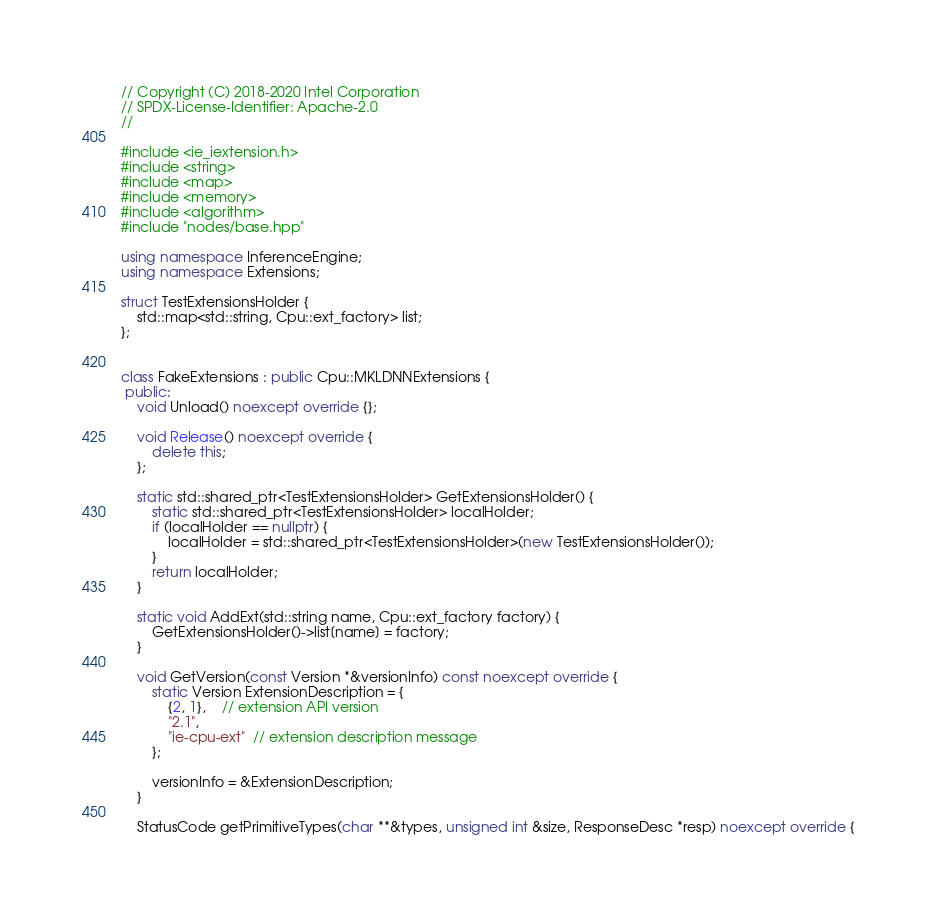<code> <loc_0><loc_0><loc_500><loc_500><_C++_>// Copyright (C) 2018-2020 Intel Corporation
// SPDX-License-Identifier: Apache-2.0
//

#include <ie_iextension.h>
#include <string>
#include <map>
#include <memory>
#include <algorithm>
#include "nodes/base.hpp"

using namespace InferenceEngine;
using namespace Extensions;

struct TestExtensionsHolder {
    std::map<std::string, Cpu::ext_factory> list;
};


class FakeExtensions : public Cpu::MKLDNNExtensions {
 public:
    void Unload() noexcept override {};

    void Release() noexcept override {
        delete this;
    };

    static std::shared_ptr<TestExtensionsHolder> GetExtensionsHolder() {
        static std::shared_ptr<TestExtensionsHolder> localHolder;
        if (localHolder == nullptr) {
            localHolder = std::shared_ptr<TestExtensionsHolder>(new TestExtensionsHolder());
        }
        return localHolder;
    }

    static void AddExt(std::string name, Cpu::ext_factory factory) {
        GetExtensionsHolder()->list[name] = factory;
    }

    void GetVersion(const Version *&versionInfo) const noexcept override {
        static Version ExtensionDescription = {
            {2, 1},    // extension API version
            "2.1",
            "ie-cpu-ext"  // extension description message
        };

        versionInfo = &ExtensionDescription;
    }

    StatusCode getPrimitiveTypes(char **&types, unsigned int &size, ResponseDesc *resp) noexcept override {</code> 